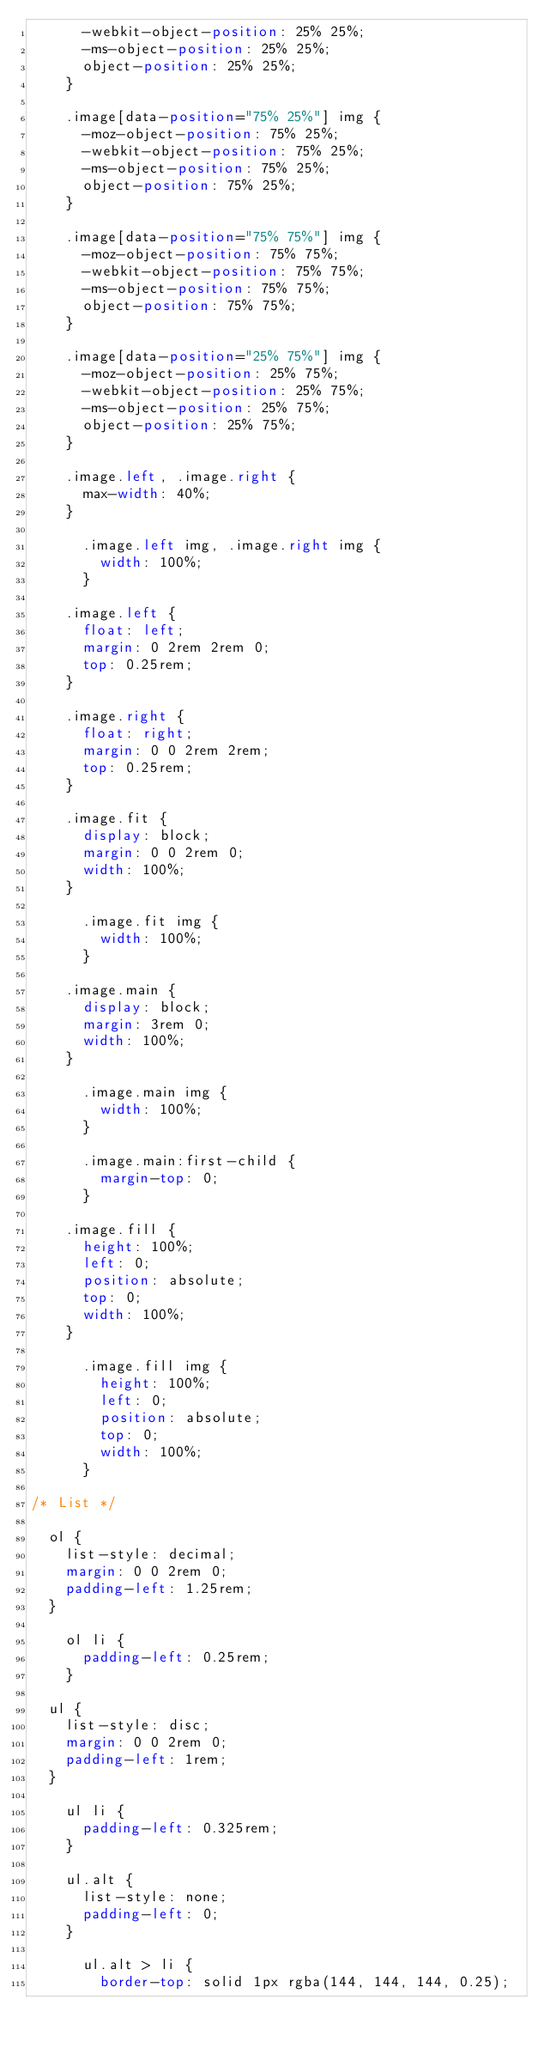<code> <loc_0><loc_0><loc_500><loc_500><_CSS_>			-webkit-object-position: 25% 25%;
			-ms-object-position: 25% 25%;
			object-position: 25% 25%;
		}

		.image[data-position="75% 25%"] img {
			-moz-object-position: 75% 25%;
			-webkit-object-position: 75% 25%;
			-ms-object-position: 75% 25%;
			object-position: 75% 25%;
		}

		.image[data-position="75% 75%"] img {
			-moz-object-position: 75% 75%;
			-webkit-object-position: 75% 75%;
			-ms-object-position: 75% 75%;
			object-position: 75% 75%;
		}

		.image[data-position="25% 75%"] img {
			-moz-object-position: 25% 75%;
			-webkit-object-position: 25% 75%;
			-ms-object-position: 25% 75%;
			object-position: 25% 75%;
		}

		.image.left, .image.right {
			max-width: 40%;
		}

			.image.left img, .image.right img {
				width: 100%;
			}

		.image.left {
			float: left;
			margin: 0 2rem 2rem 0;
			top: 0.25rem;
		}

		.image.right {
			float: right;
			margin: 0 0 2rem 2rem;
			top: 0.25rem;
		}

		.image.fit {
			display: block;
			margin: 0 0 2rem 0;
			width: 100%;
		}

			.image.fit img {
				width: 100%;
			}

		.image.main {
			display: block;
			margin: 3rem 0;
			width: 100%;
		}

			.image.main img {
				width: 100%;
			}

			.image.main:first-child {
				margin-top: 0;
			}

		.image.fill {
			height: 100%;
			left: 0;
			position: absolute;
			top: 0;
			width: 100%;
		}

			.image.fill img {
				height: 100%;
				left: 0;
				position: absolute;
				top: 0;
				width: 100%;
			}

/* List */

	ol {
		list-style: decimal;
		margin: 0 0 2rem 0;
		padding-left: 1.25rem;
	}

		ol li {
			padding-left: 0.25rem;
		}

	ul {
		list-style: disc;
		margin: 0 0 2rem 0;
		padding-left: 1rem;
	}

		ul li {
			padding-left: 0.325rem;
		}

		ul.alt {
			list-style: none;
			padding-left: 0;
		}

			ul.alt > li {
				border-top: solid 1px rgba(144, 144, 144, 0.25);</code> 